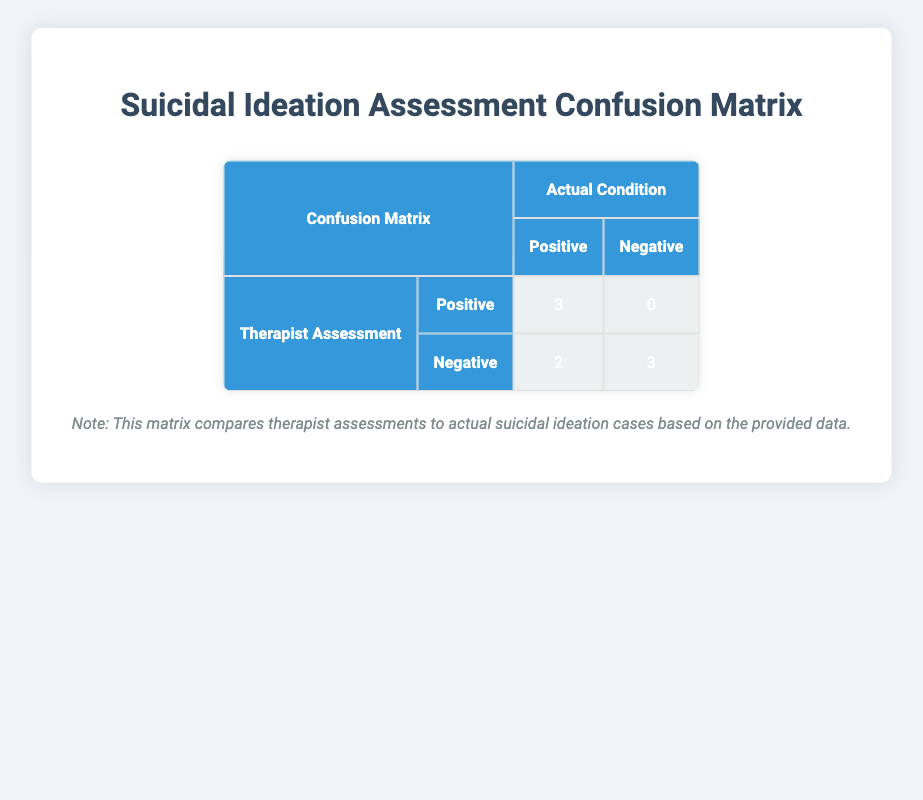What is the number of true positives in the therapist assessment? The table indicates that the true positives (TP) correspond to the cases where the therapist assessment was positive and suicidal ideation was also present. From the matrix, the value in that cell is 3.
Answer: 3 How many false negatives are there in the therapist assessment? The false negatives (FN) are the cases where the therapist assessment was negative while there was actual suicidal ideation. According to the table, the value for false negatives is 2.
Answer: 2 What is the total number of cases assessed by the therapist? To find the total, we need to add all cases together from both positive and negative assessments. The table shows 3 true positives, 0 false positives, 2 false negatives, and 3 true negatives. So, total cases = 3 + 0 + 2 + 3 = 8.
Answer: 8 Is there any case where the therapist assessment was positive, but there was no actual suicidal ideation? The table shows that false positives are the cases where the therapist assessed positively while suicidal ideation was not present. From the confusion matrix, the value for false positives is 0, indicating that there were no such cases.
Answer: No What percentage of assessments were correctly identified as true negatives? To find this percentage, we calculate the number of true negatives divided by the total number of actual negative cases. The table shows 3 true negatives and 3 total actual negatives (3 true negatives + 0 false positives). Thus, the calculation is (3/3) * 100 = 100%.
Answer: 100% How many total cases indicated suicidal ideation based on the therapist assessments? We need to sum the true positives and false negatives as they represent all cases with suicidal ideation. From the matrix, TP = 3 and FN = 2, so total = 3 + 2 = 5.
Answer: 5 What is the difference between true positives and true negatives? The true positives corresponding to actual suicidal ideation are 3, while the true negatives indicating no suicidal ideation are 3. The difference is calculated as 3 - 3 = 0.
Answer: 0 What is the ratio of false positives to true positives? The ratio can be calculated by taking the number of false positives (0) and dividing it by the number of true positives (3). Therefore, the ratio is 0/3, which simplifies to 0.
Answer: 0 